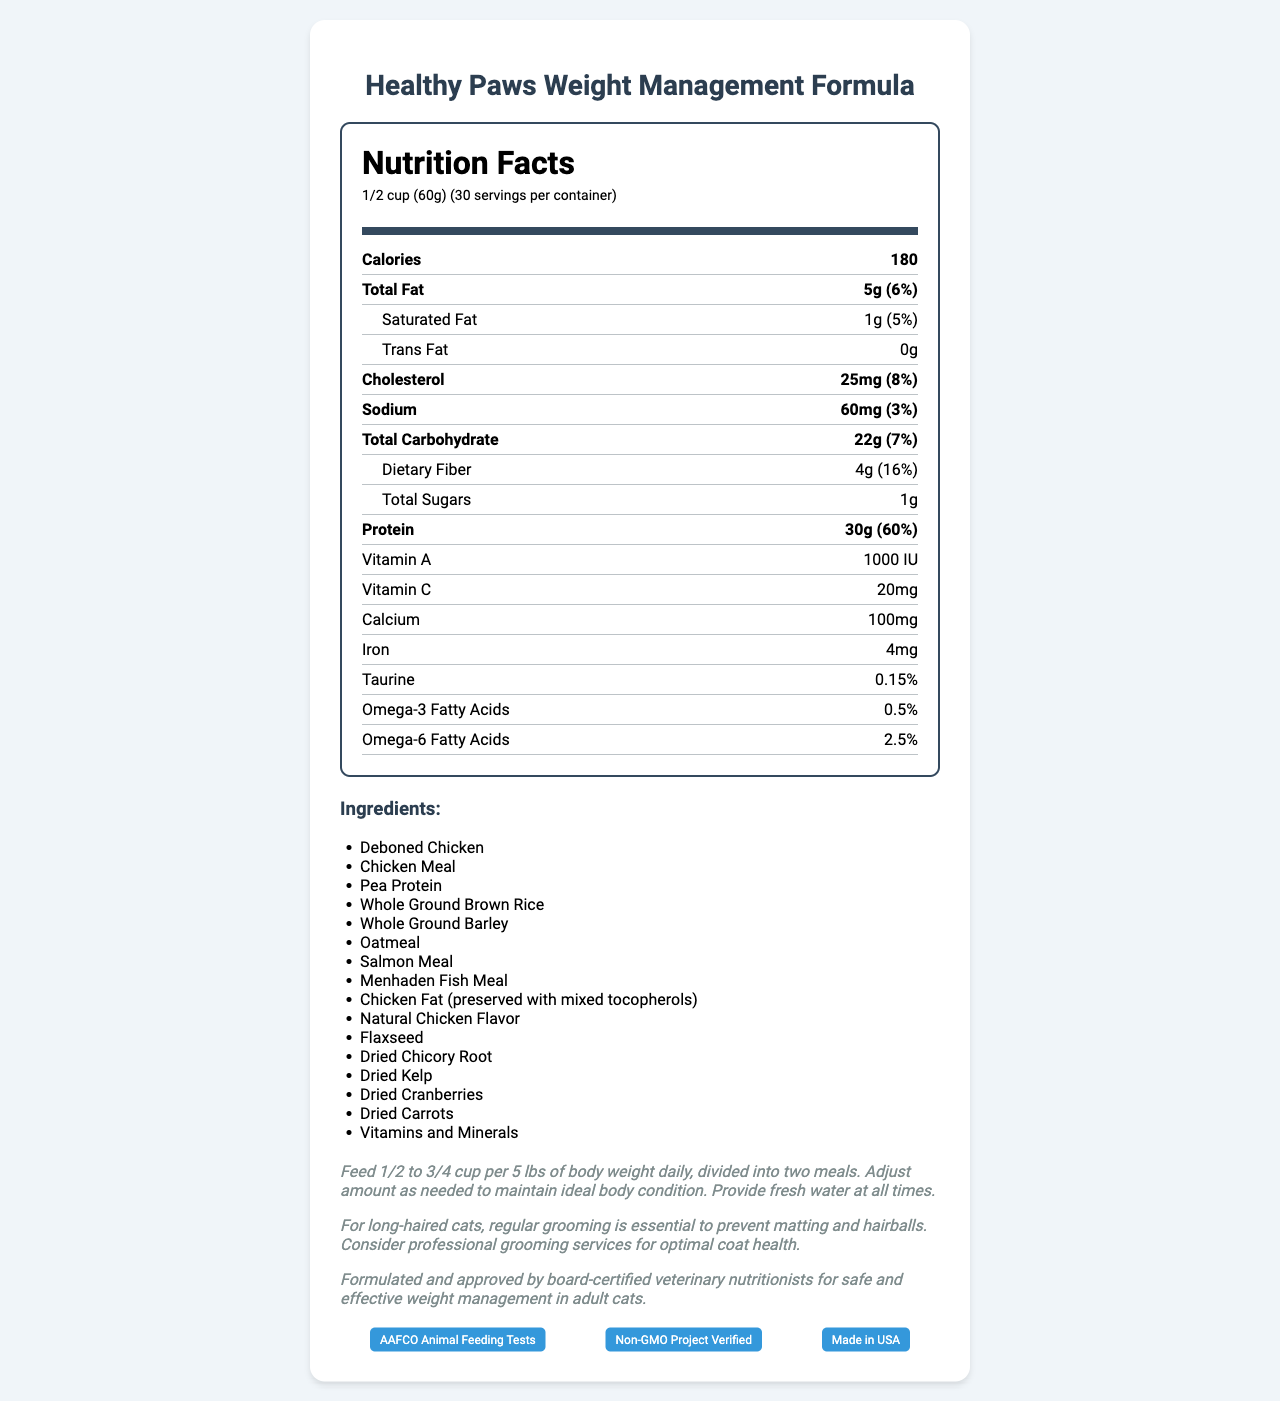what is the serving size? The serving size is mentioned at the beginning of the document under the header "Nutrition Facts."
Answer: 1/2 cup (60g) how much protein is in one serving? The protein amount per serving is listed under the "Nutrition Facts" section as 30g.
Answer: 30g what is the calorie content per serving? The calorie content per serving is specified as 180 calories in the "Nutrition Facts" section.
Answer: 180 what is the percentage daily value of total fat? The document states that the percent daily value of total fat is 6%.
Answer: 6% how many servings are in the container? The document specifies 30 servings per container.
Answer: 30 what are the main ingredients in the cat food? The main ingredients are listed under the "Ingredients" section, starting with Deboned Chicken, Chicken Meal, Pea Protein, and so forth.
Answer: Deboned Chicken, Chicken Meal, Pea Protein, etc. what percentage of the product is taurine? The taurine content is provided under the "Nutrition Facts" section as 0.15%.
Answer: 0.15% what is the feeding instruction for a 10 lb cat? The feeding instructions say to feed 1/2 to 3/4 cup per 5 lbs of body weight daily, divided into two meals.
Answer: 1 to 1 1/2 cups daily, divided into 2 meals which certification does the cat food have? A. USDA Organic B. AAFCO Approved C. Non-GMO Project Verified The certifications listed include "Non-GMO Project Verified," "AAFCO Animal Feeding Tests," and "Made in USA."
Answer: C. Non-GMO Project Verified who manufactured the cat food? A. Pet Nutrition Co. B. Feline Nutrition Experts, Inc. C. Cat Care Products The manufacturer is listed as "Feline Nutrition Experts, Inc." in the "Manufacturer Info" section.
Answer: B. Feline Nutrition Experts, Inc. is this cat food formulated by veterinarians? The document states that the food is "Formulated and approved by board-certified veterinary nutritionists."
Answer: Yes does the cat food contain any fish products? The ingredients list includes items such as Salmon Meal and Menhaden Fish Meal.
Answer: Yes does this product contain GMO ingredients? While the product is "Non-GMO Project Verified," the document does not specifically state that it contains no GMO ingredients.
Answer: Cannot be determined summarize the main idea of the document. This summary covers the key points listed in the document, such as nutritional facts, ingredients, feeding instructions, and certifications.
Answer: The document provides detailed nutritional information for "Healthy Paws Weight Management Formula" cat food. It includes the serving size, calorie content, percentages of daily values for various nutrients, ingredients, feeding instructions, notes for long-haired cats, and certifications. The product is manufactured by Feline Nutrition Experts, Inc. and is formulated by board-certified veterinary nutritionists. 